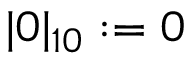Convert formula to latex. <formula><loc_0><loc_0><loc_500><loc_500>| 0 | _ { 1 0 } \colon = 0</formula> 